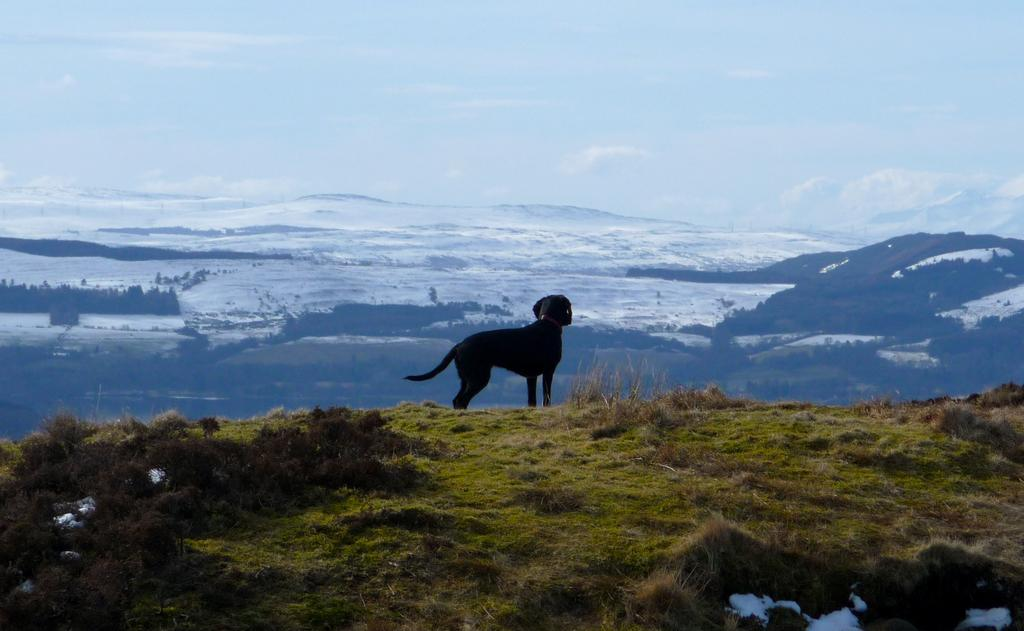What type of animal is standing in the image? There is a black dog standing in the image. What can be seen at the bottom of the image? Plants, grass, and snow are visible at the bottom of the image. What is visible in the background of the image? Hills, snow, trees, and the sky are visible in the background of the image. What type of bag can be seen hanging from the tree in the image? There is no bag present in the image; it features a black dog, plants, grass, snow, hills, trees, and the sky. Can you see a playground in the image? There is no playground present in the image. 